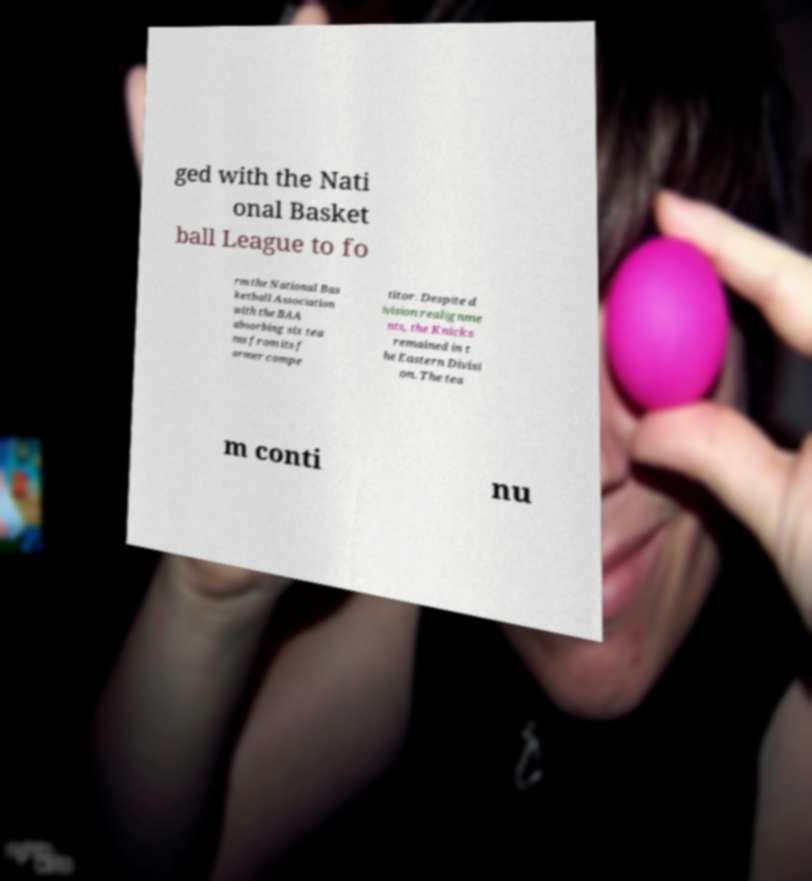Could you assist in decoding the text presented in this image and type it out clearly? ged with the Nati onal Basket ball League to fo rm the National Bas ketball Association with the BAA absorbing six tea ms from its f ormer compe titor. Despite d ivision realignme nts, the Knicks remained in t he Eastern Divisi on. The tea m conti nu 